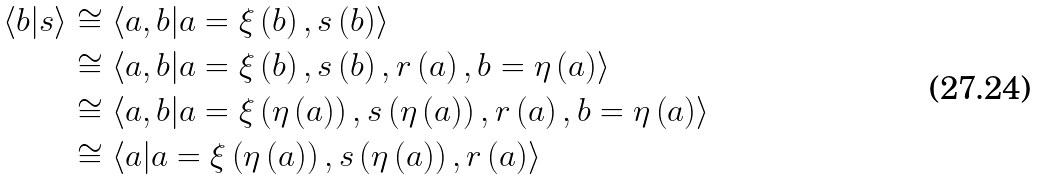Convert formula to latex. <formula><loc_0><loc_0><loc_500><loc_500>\left \langle b | s \right \rangle & \cong \left \langle a , b | a = \xi \left ( b \right ) , s \left ( b \right ) \right \rangle \\ & \cong \left \langle a , b | a = \xi \left ( b \right ) , s \left ( b \right ) , r \left ( a \right ) , b = \eta \left ( a \right ) \right \rangle \\ & \cong \left \langle a , b | a = \xi \left ( \eta \left ( a \right ) \right ) , s \left ( \eta \left ( a \right ) \right ) , r \left ( a \right ) , b = \eta \left ( a \right ) \right \rangle \\ & \cong \left \langle a | a = \xi \left ( \eta \left ( a \right ) \right ) , s \left ( \eta \left ( a \right ) \right ) , r \left ( a \right ) \right \rangle</formula> 